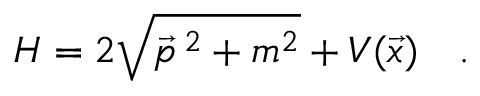<formula> <loc_0><loc_0><loc_500><loc_500>H = 2 \sqrt { \vec { p } ^ { 2 } + m ^ { 2 } } + V ( \vec { x } ) \quad .</formula> 